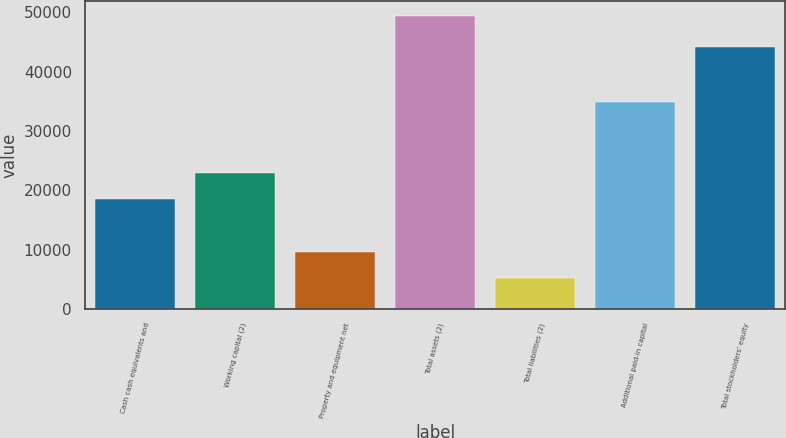Convert chart to OTSL. <chart><loc_0><loc_0><loc_500><loc_500><bar_chart><fcel>Cash cash equivalents and<fcel>Working capital (2)<fcel>Property and equipment net<fcel>Total assets (2)<fcel>Total liabilities (2)<fcel>Additional paid-in capital<fcel>Total stockholders' equity<nl><fcel>18434<fcel>22855.8<fcel>9610.8<fcel>49407<fcel>5189<fcel>34886<fcel>44218<nl></chart> 